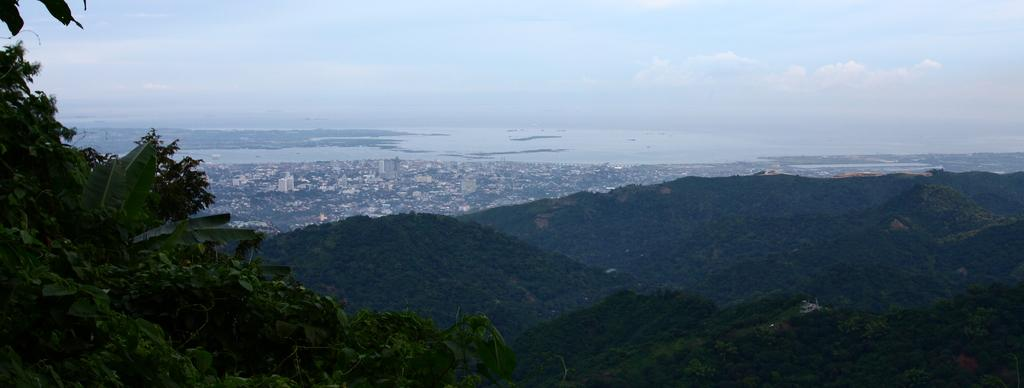What type of vegetation is on the left side of the image? There are trees on the left side of the image. What geographical features can be seen in the middle of the image? There are hills in the middle of the image. What natural element is visible at the back side of the image? There is water visible at the back side of the image. What is visible at the top of the image? The sky is visible at the top of the image. How many sheep are visible in the image? There are no sheep present in the image. What type of tool is used to wash the trees in the image? There is no tool used to wash the trees in the image, as trees do not require washing. 